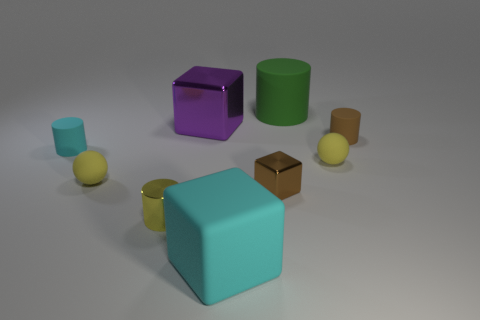Subtract all blocks. How many objects are left? 6 Subtract 0 blue cylinders. How many objects are left? 9 Subtract all tiny brown things. Subtract all brown rubber cylinders. How many objects are left? 6 Add 3 small brown blocks. How many small brown blocks are left? 4 Add 3 cyan rubber things. How many cyan rubber things exist? 5 